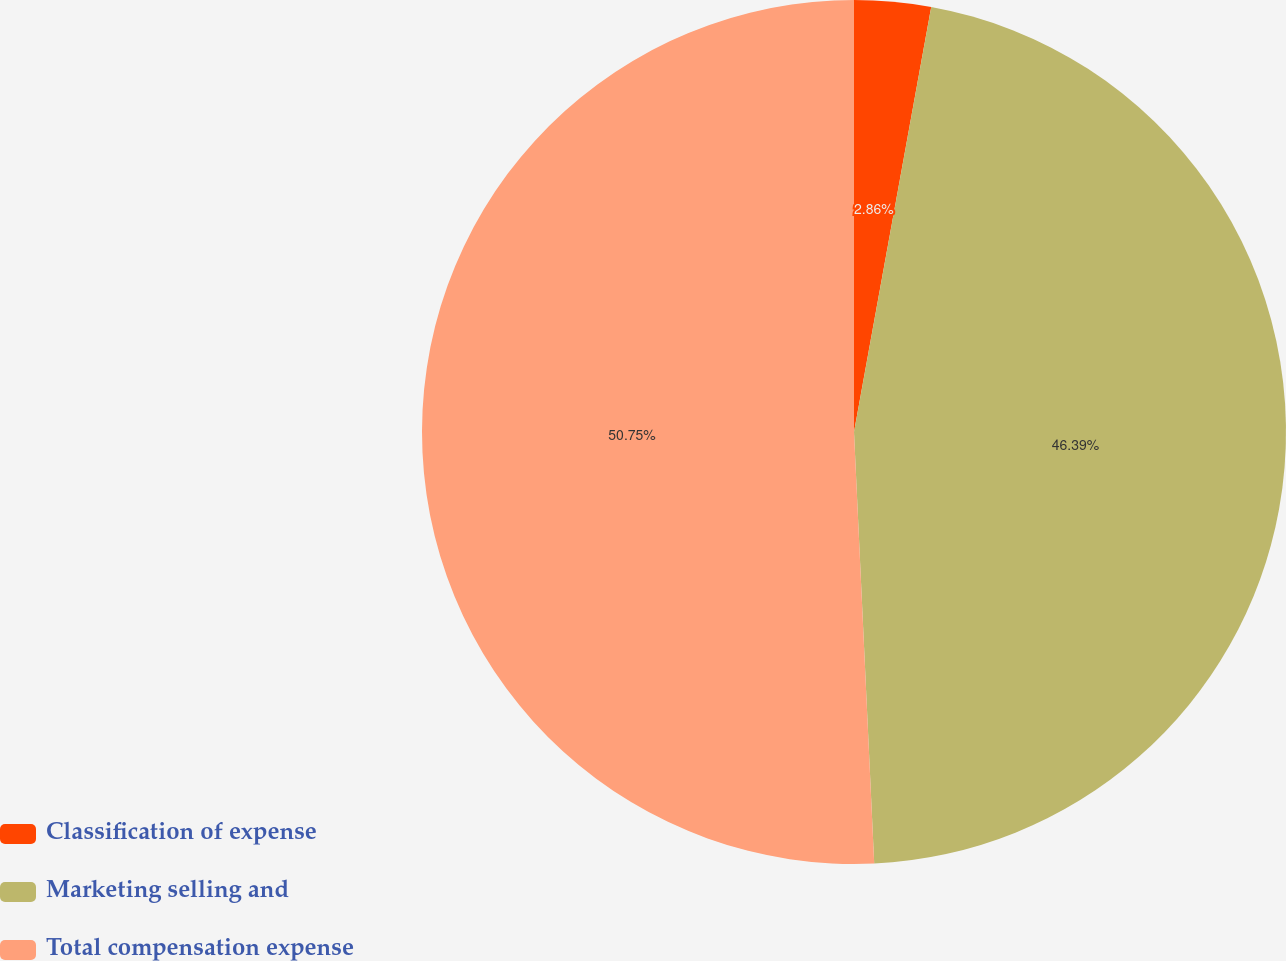<chart> <loc_0><loc_0><loc_500><loc_500><pie_chart><fcel>Classification of expense<fcel>Marketing selling and<fcel>Total compensation expense<nl><fcel>2.86%<fcel>46.39%<fcel>50.74%<nl></chart> 